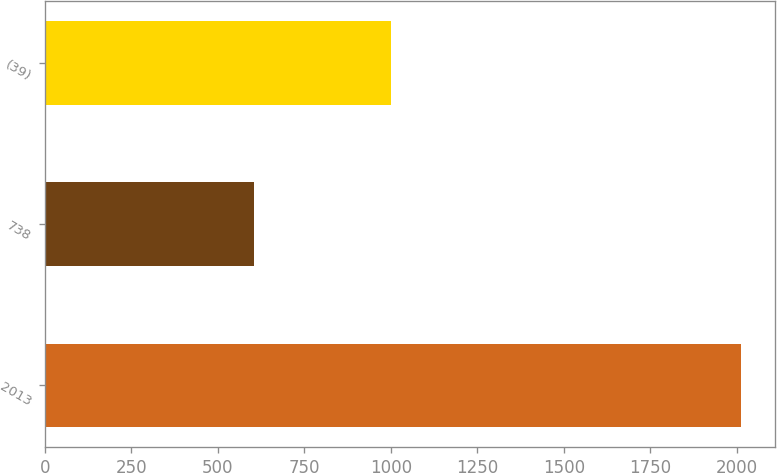Convert chart to OTSL. <chart><loc_0><loc_0><loc_500><loc_500><bar_chart><fcel>2013<fcel>738<fcel>(39)<nl><fcel>2011<fcel>606<fcel>1000<nl></chart> 